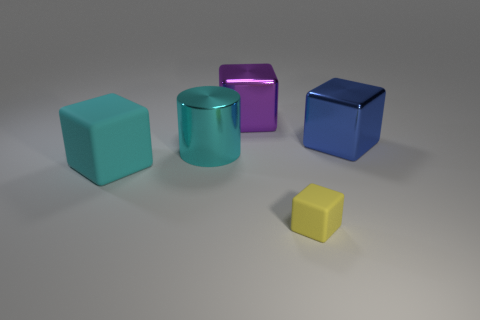Is there a cyan metal cylinder that has the same size as the purple thing?
Ensure brevity in your answer.  Yes. What number of metal objects are cylinders or small brown objects?
Your response must be concise. 1. The big metal thing that is the same color as the large rubber thing is what shape?
Your answer should be compact. Cylinder. How many large cylinders are there?
Provide a succinct answer. 1. Is the material of the large thing that is right of the purple object the same as the cube to the left of the big purple object?
Give a very brief answer. No. There is a block that is made of the same material as the big blue object; what size is it?
Offer a very short reply. Large. There is a cyan object that is right of the cyan cube; what is its shape?
Your answer should be very brief. Cylinder. Does the large object that is left of the large cyan shiny object have the same color as the large metallic thing that is to the left of the purple shiny object?
Offer a terse response. Yes. There is a block that is the same color as the metal cylinder; what size is it?
Your answer should be very brief. Large. Are there any cyan rubber things?
Your answer should be very brief. Yes. 